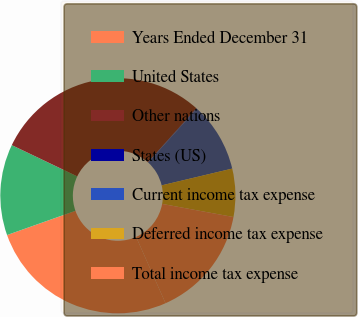Convert chart to OTSL. <chart><loc_0><loc_0><loc_500><loc_500><pie_chart><fcel>Years Ended December 31<fcel>United States<fcel>Other nations<fcel>States (US)<fcel>Current income tax expense<fcel>Deferred income tax expense<fcel>Total income tax expense<nl><fcel>26.23%<fcel>12.51%<fcel>29.56%<fcel>0.08%<fcel>9.56%<fcel>6.61%<fcel>15.46%<nl></chart> 